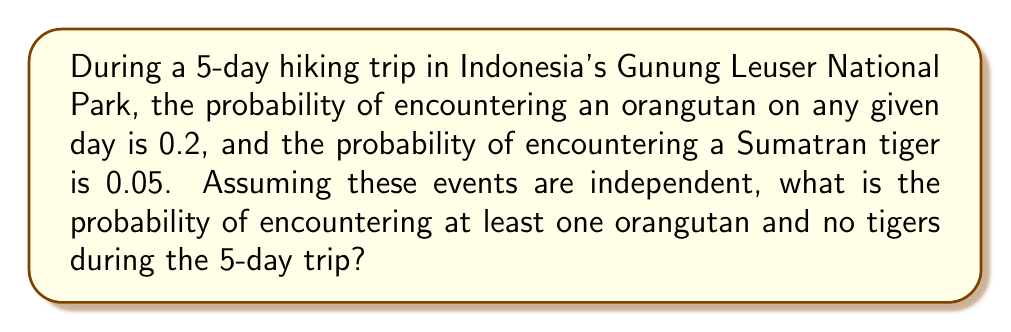Help me with this question. Let's approach this step-by-step:

1) First, let's calculate the probability of encountering at least one orangutan during the 5-day trip.
   - The probability of not encountering an orangutan on a single day is $1 - 0.2 = 0.8$
   - The probability of not encountering an orangutan for all 5 days is $0.8^5$
   - Therefore, the probability of encountering at least one orangutan is $1 - 0.8^5$

2) Now, let's calculate the probability of not encountering any tigers during the 5-day trip.
   - The probability of not encountering a tiger on a single day is $1 - 0.05 = 0.95$
   - The probability of not encountering a tiger for all 5 days is $0.95^5$

3) Since we want both events to occur (at least one orangutan AND no tigers), and these events are independent, we multiply their probabilities:

   $P(\text{at least one orangutan and no tigers}) = (1 - 0.8^5) \times 0.95^5$

4) Let's calculate:
   $1 - 0.8^5 = 1 - 0.32768 = 0.67232$
   $0.95^5 = 0.77378125$

5) Final calculation:
   $0.67232 \times 0.77378125 = 0.52021$

Therefore, the probability is approximately 0.52021 or 52.021%.
Answer: $0.52021$ or $52.021\%$ 